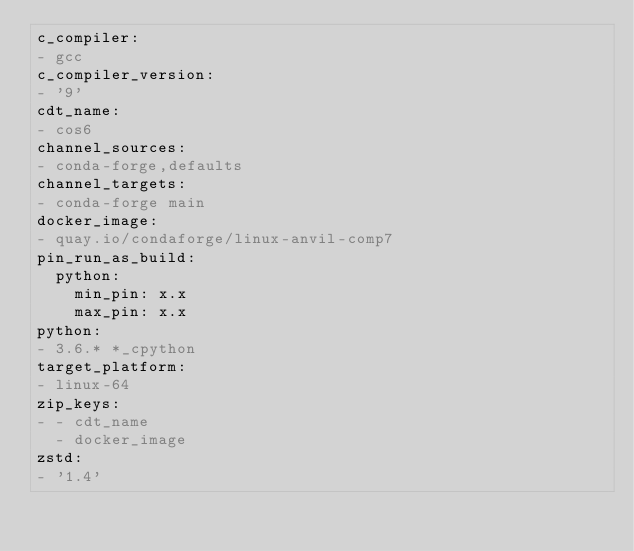Convert code to text. <code><loc_0><loc_0><loc_500><loc_500><_YAML_>c_compiler:
- gcc
c_compiler_version:
- '9'
cdt_name:
- cos6
channel_sources:
- conda-forge,defaults
channel_targets:
- conda-forge main
docker_image:
- quay.io/condaforge/linux-anvil-comp7
pin_run_as_build:
  python:
    min_pin: x.x
    max_pin: x.x
python:
- 3.6.* *_cpython
target_platform:
- linux-64
zip_keys:
- - cdt_name
  - docker_image
zstd:
- '1.4'
</code> 